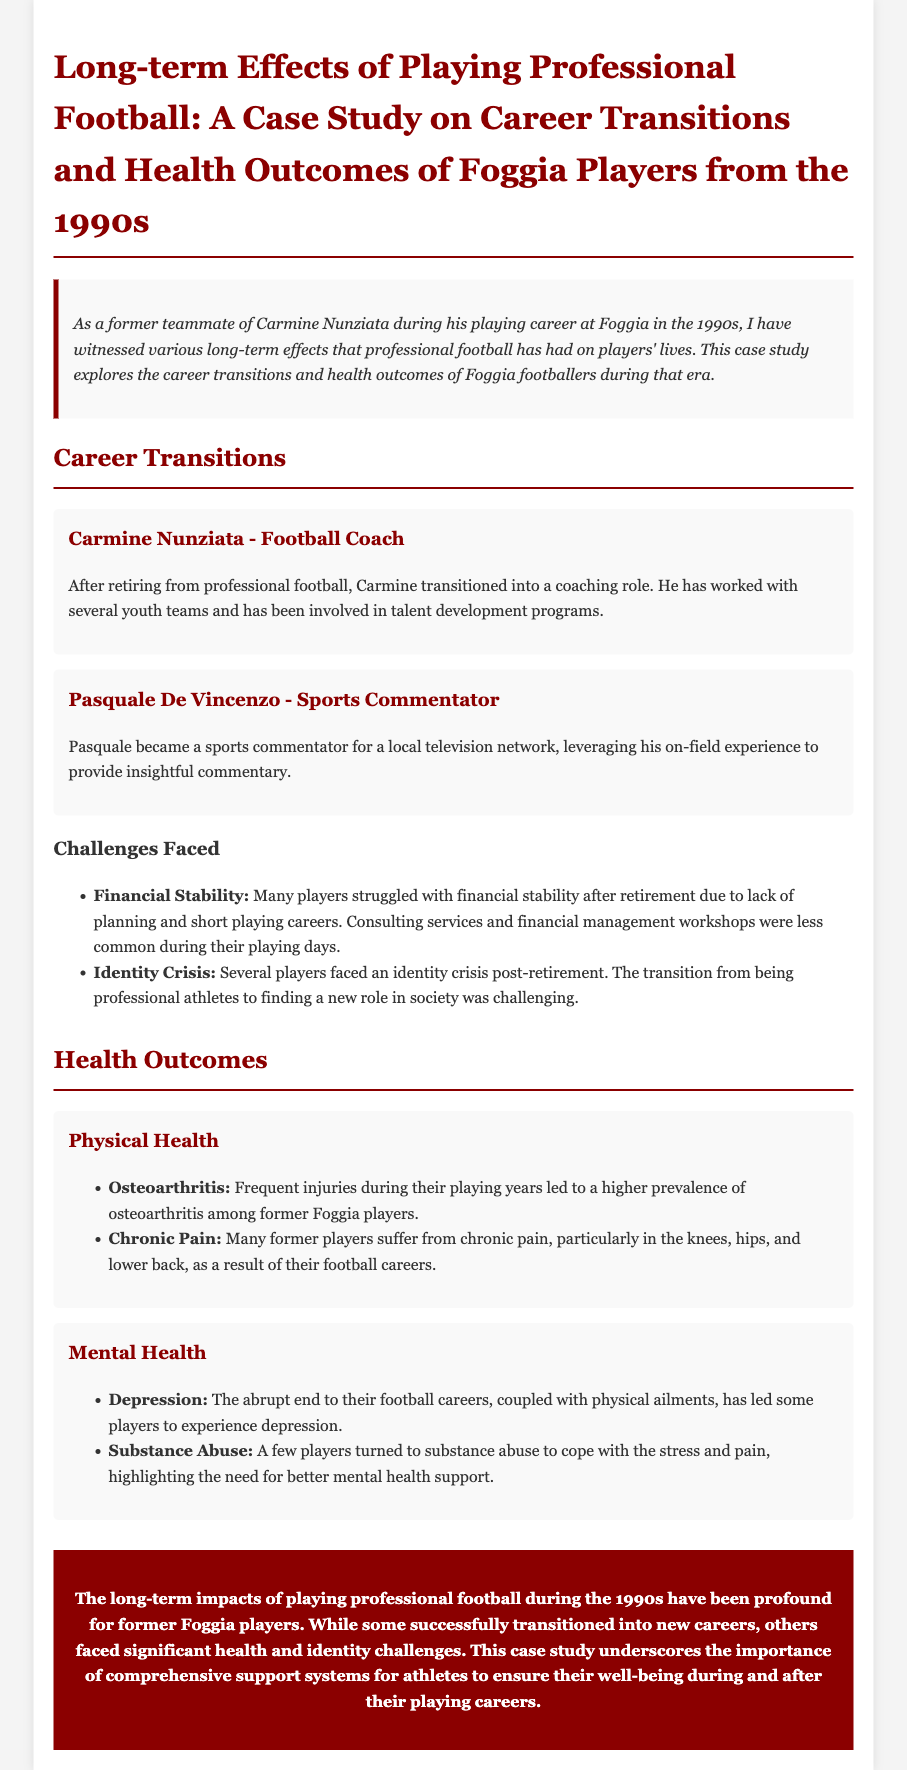What is the title of the case study? The title is stated in the document's main heading, highlighting the focus on long-term effects and career transitions of Foggia players.
Answer: Long-term Effects of Playing Professional Football: A Case Study on Career Transitions and Health Outcomes of Foggia Players from the 1990s Who is mentioned as a football coach in the study? Carmine Nunziata is noted as having transitioned into a coaching role after retirement from professional football.
Answer: Carmine Nunziata What challenge do many players face after retirement? The document lists several challenges, including financial stability and identity crisis, faced by retired players.
Answer: Financial Stability What health issue is prevalent among former Foggia players? The case study indicates a higher prevalence of osteoarthritis among these players due to frequent injuries.
Answer: Osteoarthritis What is a common mental health concern identified in the case study? The document mentions that some players experience depression as a result of their abrupt career ends.
Answer: Depression What role did Pasquale De Vincenzo take after playing football? The case study details that Pasquale became a sports commentator, utilizing his experience in the sport.
Answer: Sports Commentator What is a notable consequence of players' physical health from their careers? The ongoing chronic pain is highlighted as a significant health outcome affecting many of the former players.
Answer: Chronic Pain What does the conclusion emphasize regarding player support? The conclusion underlines the need for comprehensive support systems for athletes during and after their careers.
Answer: Comprehensive support systems What type of document is this? The overall structure and content indicate that it is a case study focusing on specific players and their outcomes after professional football.
Answer: Case study 